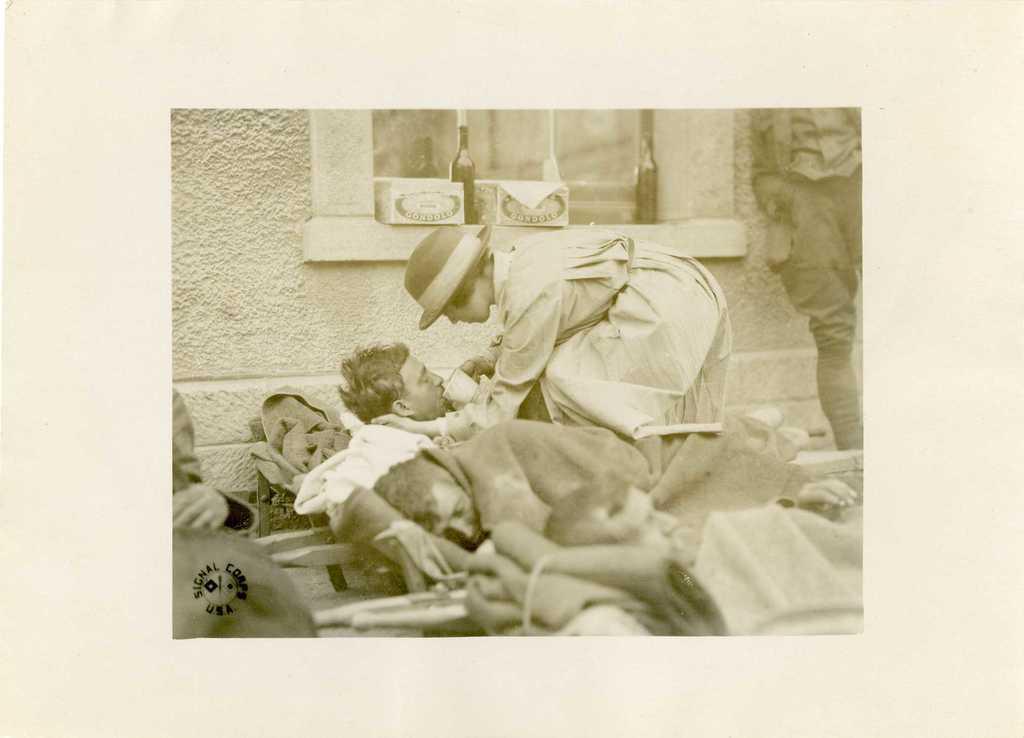Please provide a concise description of this image. In this image, I think this is a picture on the paper. I can see two people laying. Here is the woman standing and holding a cup. I can see cardboard boxes and a bottle, which are placed near the window. Here is a person standing. I can see the watermark on the image. 